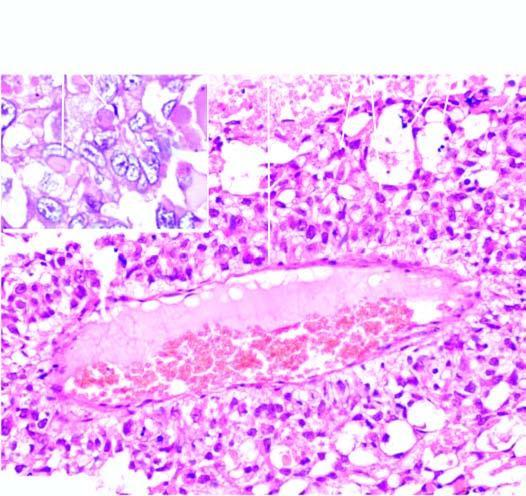does oxygen delivery show intra - and extracellular hyaline globules?
Answer the question using a single word or phrase. No 